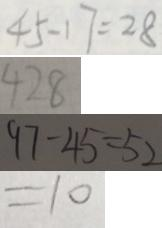<formula> <loc_0><loc_0><loc_500><loc_500>4 5 - 1 7 = 2 8 
 4 2 8 
 9 7 - 4 5 = 5 2 
 = 1 0</formula> 